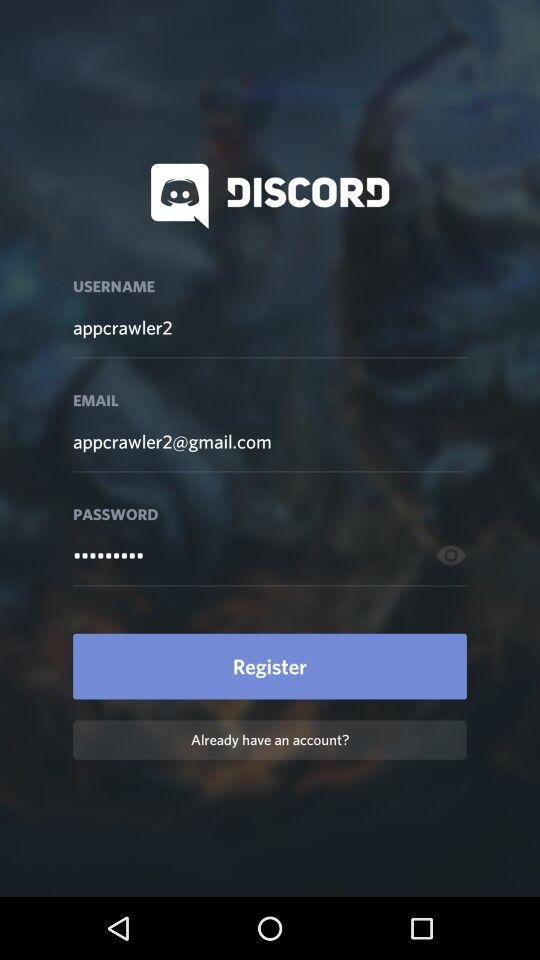What is the username? The username is "appcrawler2". 